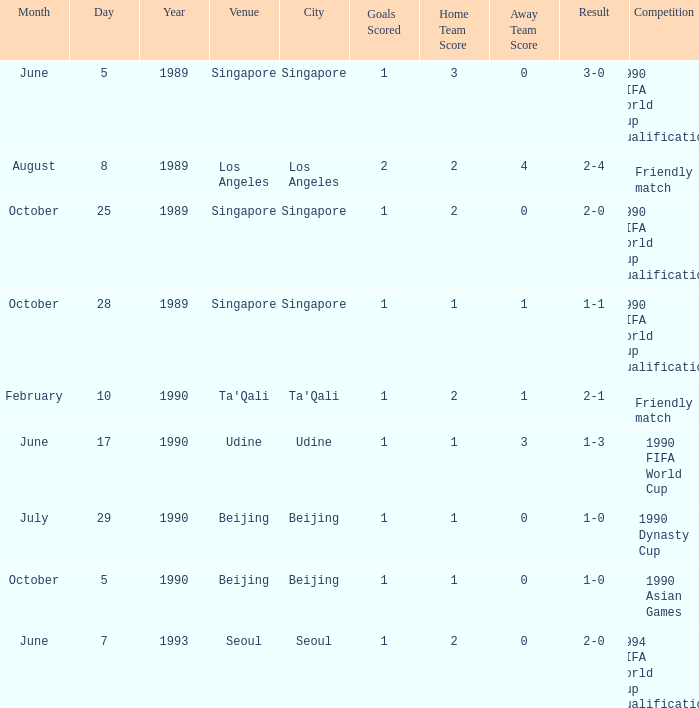What is the competition at the ta'qali venue? Friendly match. 